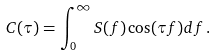<formula> <loc_0><loc_0><loc_500><loc_500>C ( \tau ) = \int ^ { \infty } _ { 0 } S ( f ) \cos ( \tau f ) d f \, .</formula> 